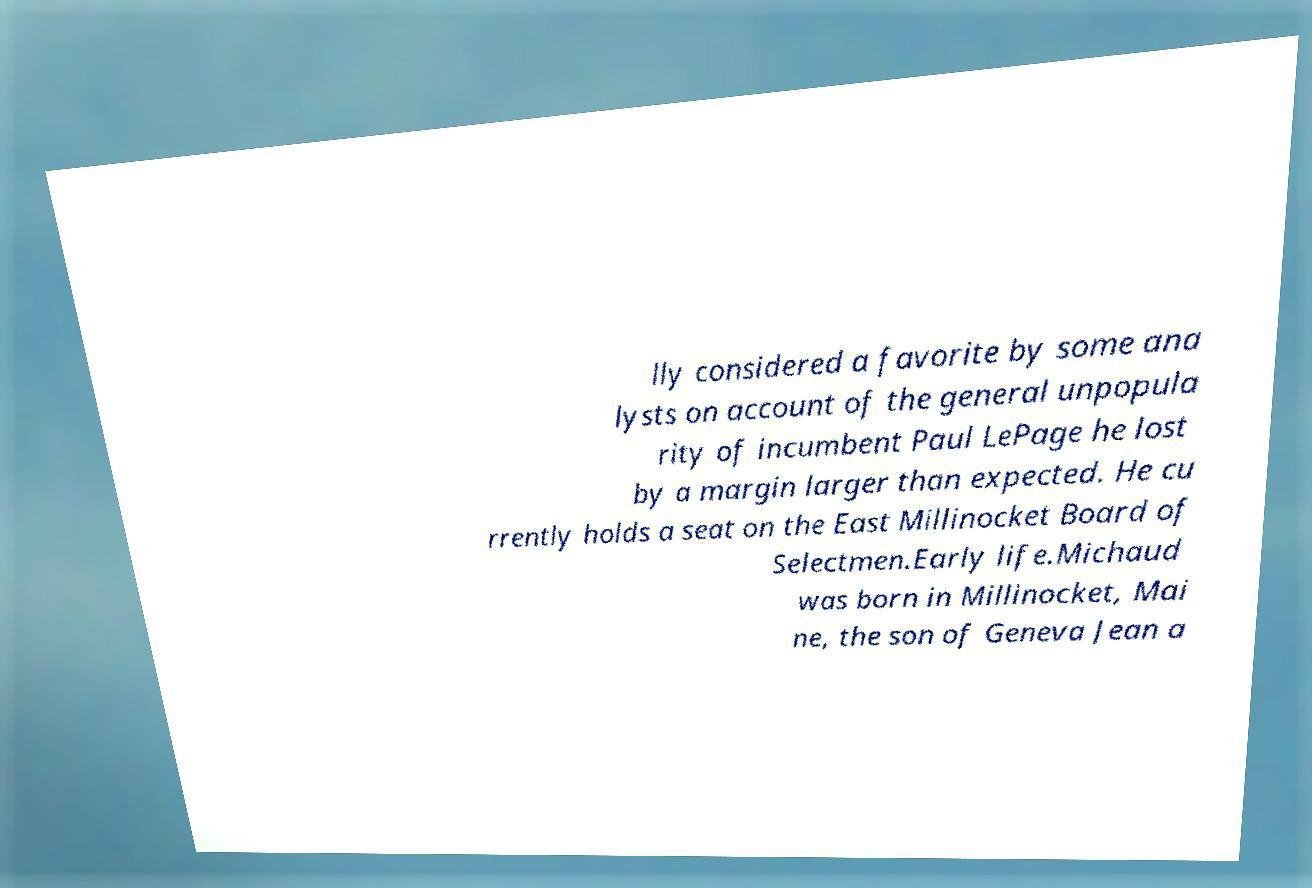There's text embedded in this image that I need extracted. Can you transcribe it verbatim? lly considered a favorite by some ana lysts on account of the general unpopula rity of incumbent Paul LePage he lost by a margin larger than expected. He cu rrently holds a seat on the East Millinocket Board of Selectmen.Early life.Michaud was born in Millinocket, Mai ne, the son of Geneva Jean a 